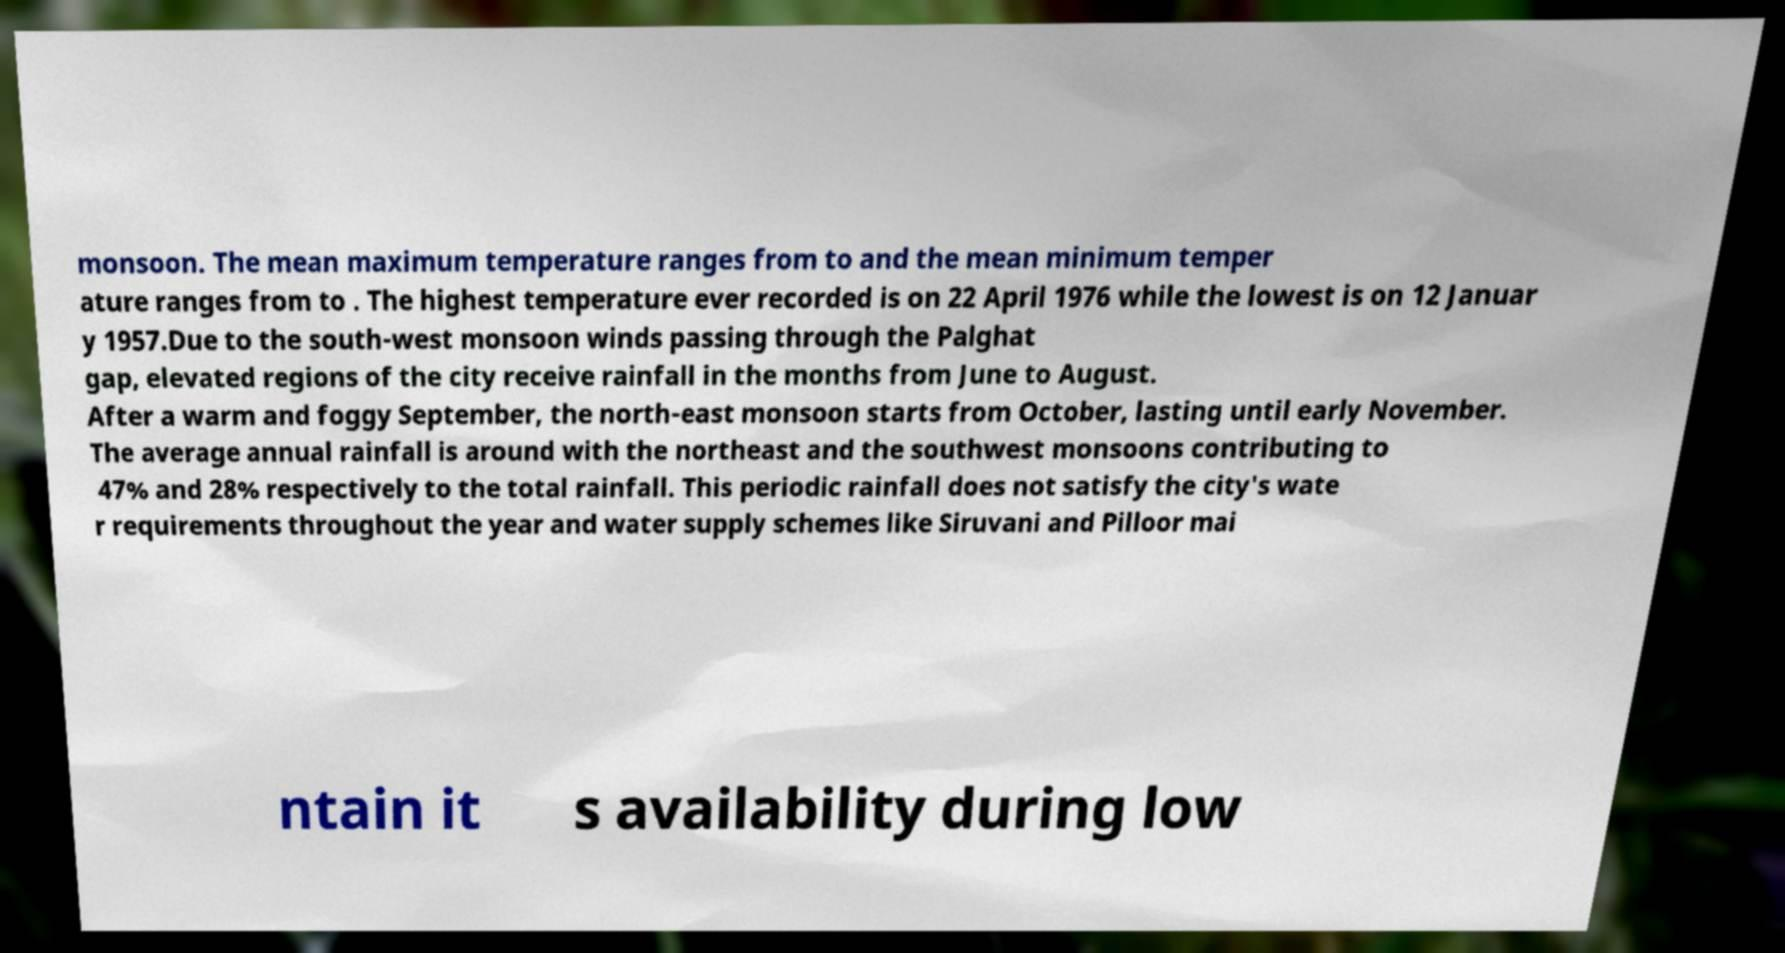For documentation purposes, I need the text within this image transcribed. Could you provide that? monsoon. The mean maximum temperature ranges from to and the mean minimum temper ature ranges from to . The highest temperature ever recorded is on 22 April 1976 while the lowest is on 12 Januar y 1957.Due to the south-west monsoon winds passing through the Palghat gap, elevated regions of the city receive rainfall in the months from June to August. After a warm and foggy September, the north-east monsoon starts from October, lasting until early November. The average annual rainfall is around with the northeast and the southwest monsoons contributing to 47% and 28% respectively to the total rainfall. This periodic rainfall does not satisfy the city's wate r requirements throughout the year and water supply schemes like Siruvani and Pilloor mai ntain it s availability during low 